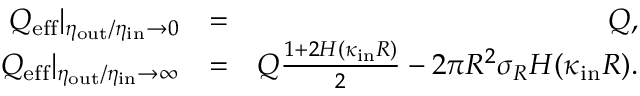Convert formula to latex. <formula><loc_0><loc_0><loc_500><loc_500>\begin{array} { r l r } { Q _ { e f f } | _ { \eta _ { o u t } / \eta _ { i n } \to 0 } } & { = } & { Q , } \\ { Q _ { e f f } | _ { \eta _ { o u t } / \eta _ { i n } \to \infty } } & { = } & { Q \frac { 1 + 2 H ( \kappa _ { i n } R ) } { 2 } - 2 \pi R ^ { 2 } \sigma _ { R } H ( \kappa _ { i n } R ) . } \end{array}</formula> 